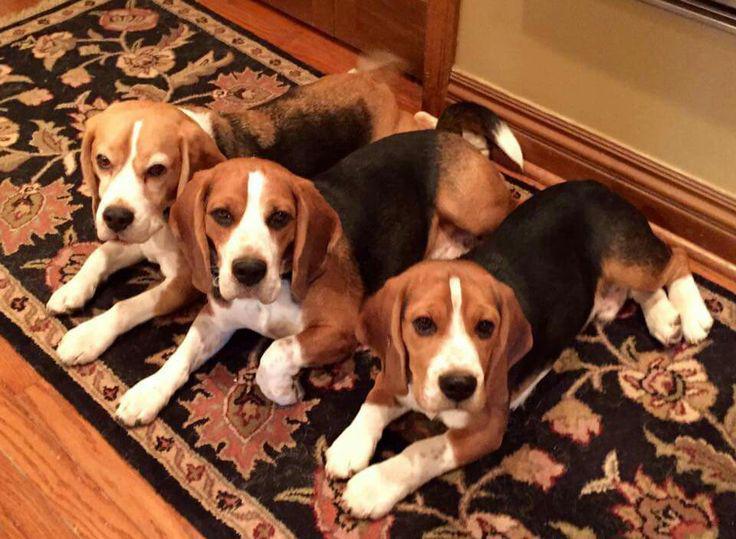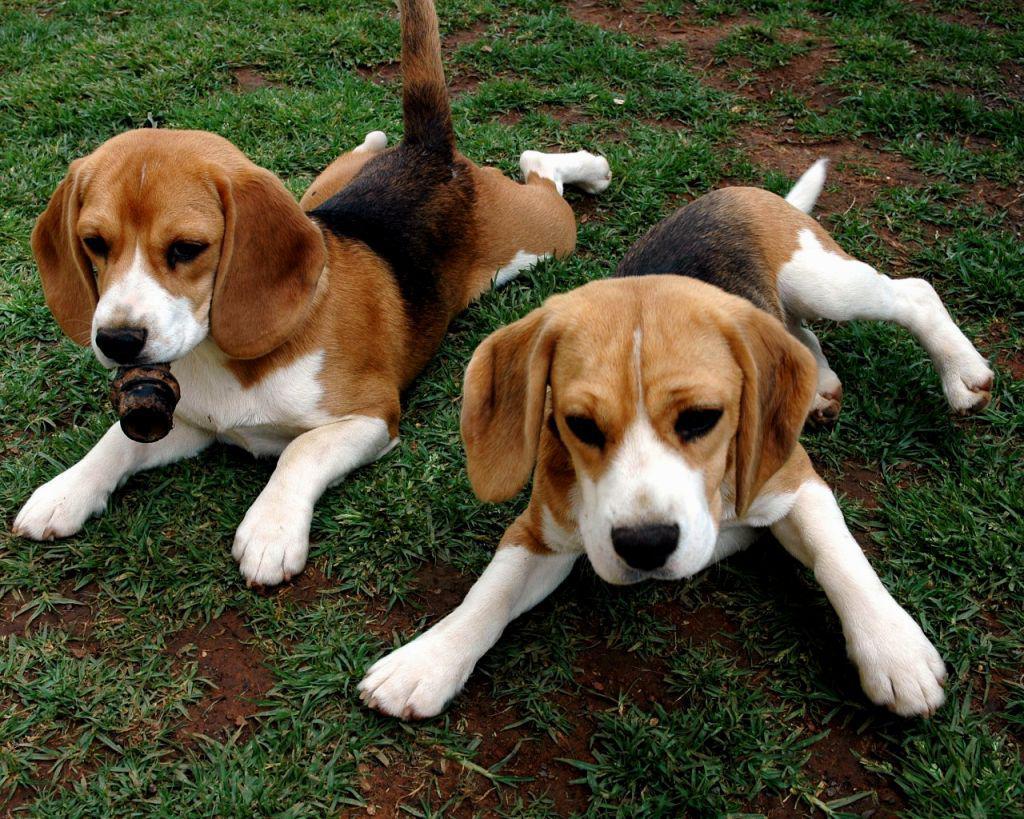The first image is the image on the left, the second image is the image on the right. Examine the images to the left and right. Is the description "There is exactly two dogs in the right image." accurate? Answer yes or no. Yes. The first image is the image on the left, the second image is the image on the right. Assess this claim about the two images: "A total of four beagles are shown, and at least one beagle is posed on an upholstered seat.". Correct or not? Answer yes or no. No. 